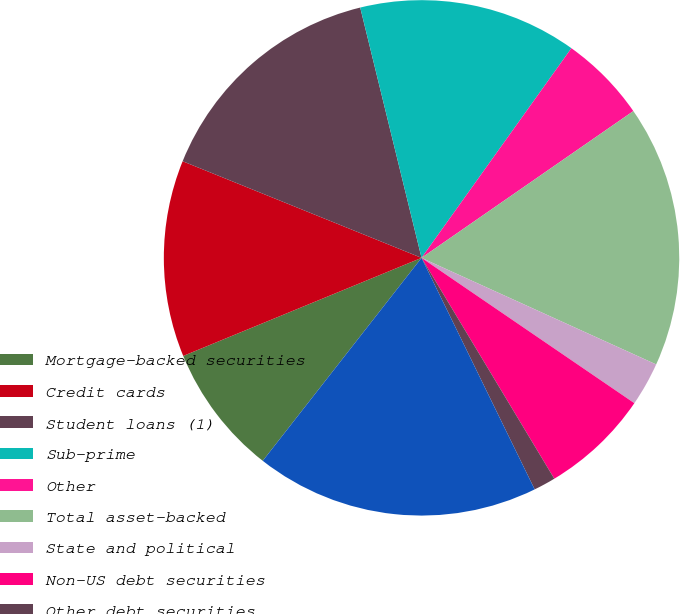Convert chart to OTSL. <chart><loc_0><loc_0><loc_500><loc_500><pie_chart><fcel>Mortgage-backed securities<fcel>Credit cards<fcel>Student loans (1)<fcel>Sub-prime<fcel>Other<fcel>Total asset-backed<fcel>State and political<fcel>Non-US debt securities<fcel>Other debt securities<fcel>Total<nl><fcel>8.22%<fcel>12.33%<fcel>15.06%<fcel>13.7%<fcel>5.48%<fcel>16.43%<fcel>2.75%<fcel>6.85%<fcel>1.38%<fcel>17.8%<nl></chart> 